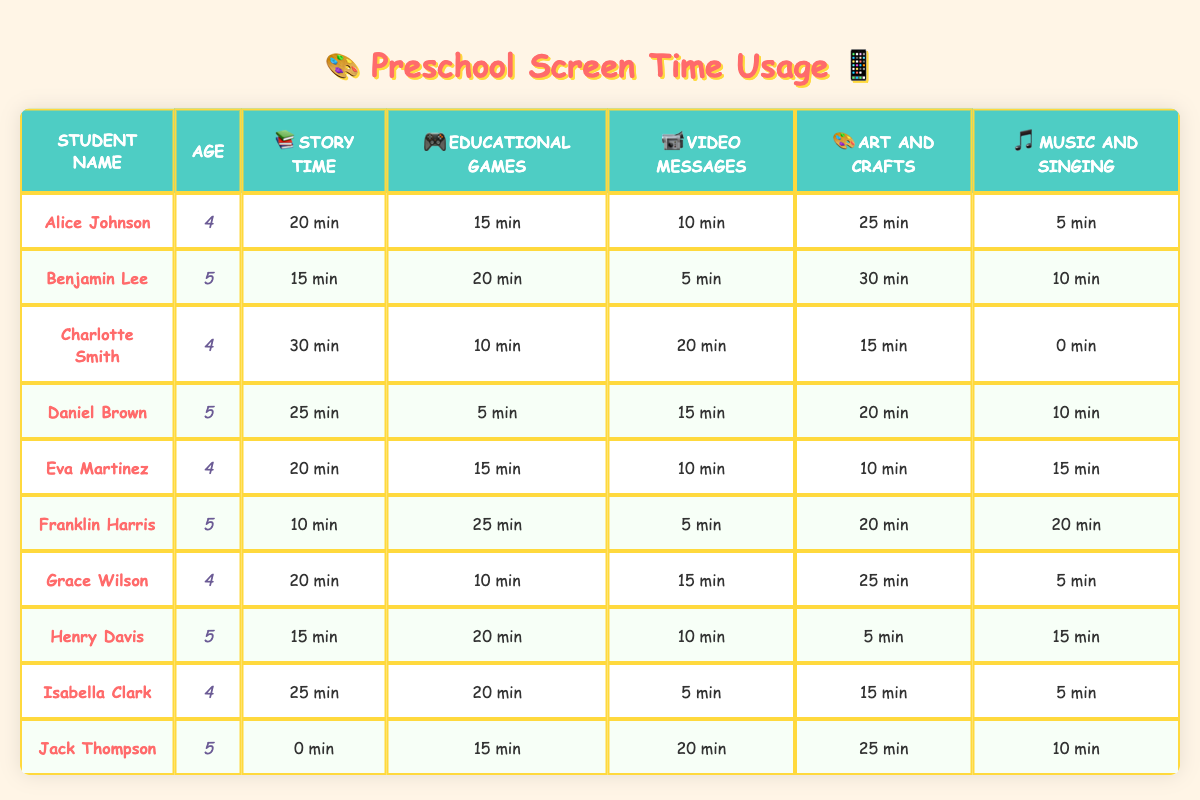What is the highest screen time for story time among the students? By looking at the table, we find that Charlotte Smith has the highest time recorded for story time, which is 30 minutes.
Answer: 30 minutes Which student spent the least amount of time on music and singing? The table shows that Charlotte Smith did not spend any time on music and singing, which is the lowest recorded time.
Answer: 0 minutes What is the average screen time spent on educational games by 5-year-olds? The 5-year-olds are Benjamin Lee (20), Daniel Brown (5), Franklin Harris (25), Henry Davis (20), and Jack Thompson (15). Summing these times gives 20 + 5 + 25 + 20 + 15 = 85. There are 5 students, so the average is 85/5 = 17 minutes.
Answer: 17 minutes Is there a student who did not participate in story time? Referring to the table, Jack Thompson has a recorded time of 0 minutes for story time, indicating he did not participate.
Answer: Yes What is the total screen time spent on art and crafts by all students? Summing the time for art and crafts for each student: 25 + 30 + 15 + 20 + 10 + 20 + 25 + 5 + 15 + 25 =  180 minutes.
Answer: 180 minutes Who spent the most time on educational games and how much was it? Looking across the table, Franklin Harris spent 25 minutes on educational games, which is the highest recorded time for this activity.
Answer: Franklin Harris, 25 minutes What percentage of Charlotte Smith's total screen time was spent on video messages? First, we calculate Charlotte's total screen time: 30 (story time) + 10 (educational games) + 20 (video messages) + 15 (art and crafts) + 0 (music and singing) = 75 minutes. The time spent on video messages is 20 minutes. Thus, the percentage is (20/75) * 100 = 26.67%.
Answer: 26.67% Which age group spent more time on music and singing? The total screen time for 4-year-olds on music and singing is 5 + 10 + 15 + 5 = 35 minutes. The 5-year-olds spent 10 + 15 + 20 = 45 minutes in total. Since 45 is greater than 35, the 5-year-olds spent more time on this activity.
Answer: 5-year-olds Did any student spend more than 30 minutes on art and crafts? Upon reviewing the table, we see that Benjamin Lee and Jack Thompson both spent 30 minutes on art and crafts, which is the only instance above 30 minutes.
Answer: Yes What is the difference in total screen time between the youngest and the oldest students? For 4-year-olds: Alice (70) + Charlotte (75) + Eva (70) + Grace (70) + Isabella (65) = 350 minutes. For 5-year-olds: Benjamin (80) + Daniel (75) + Franklin (90) + Henry (70) + Jack (70) = 385 minutes. The difference is 385 - 350 = 35 minutes.
Answer: 35 minutes 